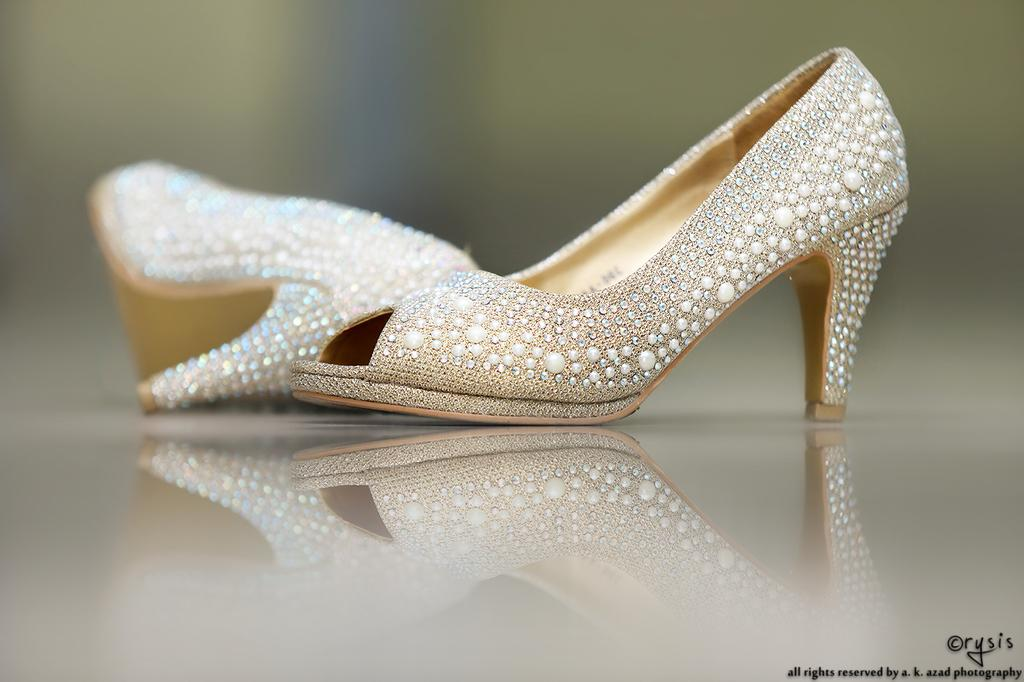What type of item is featured in the image? There is ladies' footwear in the image. What is the color of the footwear? The footwear is golden in color. What type of caption is written on the footwear in the image? There is no caption written on the footwear in the image. What type of brush is used to apply the golden color to the footwear? There is no brush or application process mentioned in the facts, as the color of the footwear is simply stated as golden. 